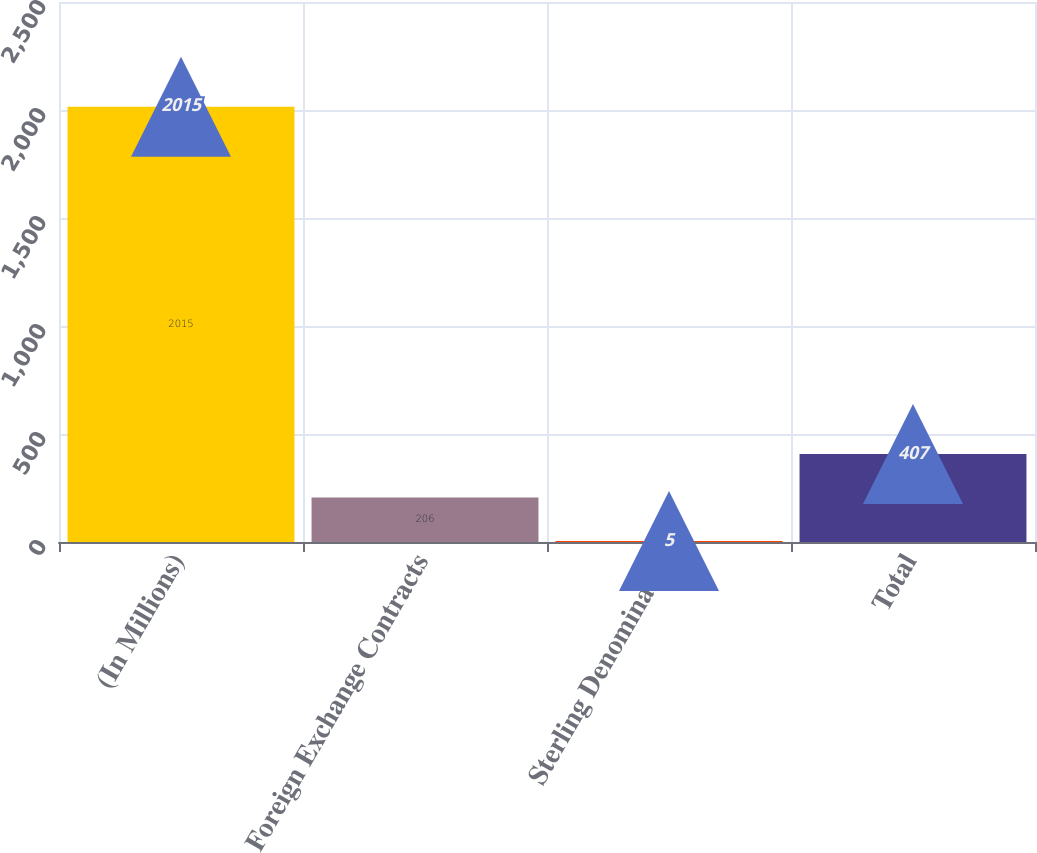<chart> <loc_0><loc_0><loc_500><loc_500><bar_chart><fcel>(In Millions)<fcel>Foreign Exchange Contracts<fcel>Sterling Denominated<fcel>Total<nl><fcel>2015<fcel>206<fcel>5<fcel>407<nl></chart> 